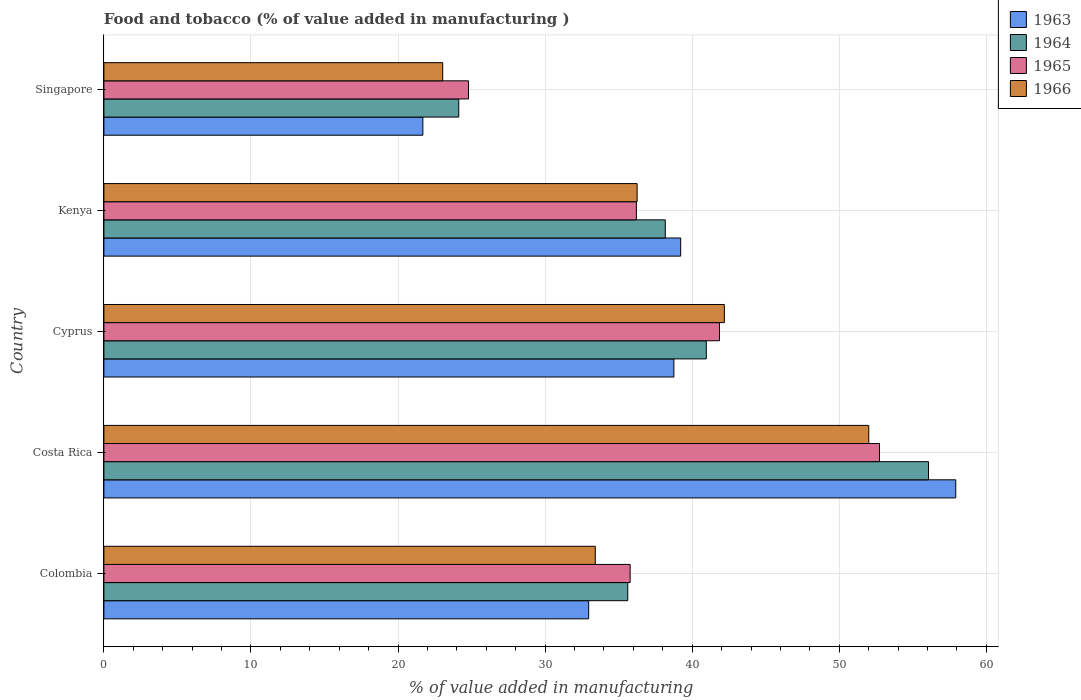How many different coloured bars are there?
Keep it short and to the point. 4. How many groups of bars are there?
Your answer should be very brief. 5. Are the number of bars on each tick of the Y-axis equal?
Make the answer very short. Yes. What is the label of the 2nd group of bars from the top?
Provide a short and direct response. Kenya. What is the value added in manufacturing food and tobacco in 1963 in Kenya?
Make the answer very short. 39.22. Across all countries, what is the maximum value added in manufacturing food and tobacco in 1965?
Ensure brevity in your answer.  52.73. Across all countries, what is the minimum value added in manufacturing food and tobacco in 1963?
Offer a terse response. 21.69. In which country was the value added in manufacturing food and tobacco in 1964 maximum?
Offer a terse response. Costa Rica. In which country was the value added in manufacturing food and tobacco in 1965 minimum?
Offer a very short reply. Singapore. What is the total value added in manufacturing food and tobacco in 1963 in the graph?
Provide a succinct answer. 190.54. What is the difference between the value added in manufacturing food and tobacco in 1964 in Colombia and that in Kenya?
Provide a succinct answer. -2.55. What is the difference between the value added in manufacturing food and tobacco in 1963 in Kenya and the value added in manufacturing food and tobacco in 1965 in Cyprus?
Your answer should be very brief. -2.64. What is the average value added in manufacturing food and tobacco in 1963 per country?
Make the answer very short. 38.11. What is the difference between the value added in manufacturing food and tobacco in 1965 and value added in manufacturing food and tobacco in 1963 in Costa Rica?
Your answer should be compact. -5.19. What is the ratio of the value added in manufacturing food and tobacco in 1966 in Colombia to that in Singapore?
Give a very brief answer. 1.45. Is the difference between the value added in manufacturing food and tobacco in 1965 in Cyprus and Singapore greater than the difference between the value added in manufacturing food and tobacco in 1963 in Cyprus and Singapore?
Provide a succinct answer. No. What is the difference between the highest and the second highest value added in manufacturing food and tobacco in 1966?
Your answer should be very brief. 9.82. What is the difference between the highest and the lowest value added in manufacturing food and tobacco in 1966?
Your answer should be compact. 28.97. What does the 3rd bar from the top in Colombia represents?
Provide a succinct answer. 1964. What does the 3rd bar from the bottom in Colombia represents?
Keep it short and to the point. 1965. Are the values on the major ticks of X-axis written in scientific E-notation?
Give a very brief answer. No. How many legend labels are there?
Provide a short and direct response. 4. What is the title of the graph?
Your response must be concise. Food and tobacco (% of value added in manufacturing ). Does "1974" appear as one of the legend labels in the graph?
Ensure brevity in your answer.  No. What is the label or title of the X-axis?
Offer a terse response. % of value added in manufacturing. What is the label or title of the Y-axis?
Provide a short and direct response. Country. What is the % of value added in manufacturing of 1963 in Colombia?
Your response must be concise. 32.96. What is the % of value added in manufacturing of 1964 in Colombia?
Keep it short and to the point. 35.62. What is the % of value added in manufacturing of 1965 in Colombia?
Make the answer very short. 35.78. What is the % of value added in manufacturing in 1966 in Colombia?
Your response must be concise. 33.41. What is the % of value added in manufacturing of 1963 in Costa Rica?
Offer a very short reply. 57.92. What is the % of value added in manufacturing of 1964 in Costa Rica?
Make the answer very short. 56.07. What is the % of value added in manufacturing of 1965 in Costa Rica?
Ensure brevity in your answer.  52.73. What is the % of value added in manufacturing of 1966 in Costa Rica?
Keep it short and to the point. 52. What is the % of value added in manufacturing of 1963 in Cyprus?
Provide a short and direct response. 38.75. What is the % of value added in manufacturing of 1964 in Cyprus?
Your answer should be compact. 40.96. What is the % of value added in manufacturing of 1965 in Cyprus?
Provide a short and direct response. 41.85. What is the % of value added in manufacturing of 1966 in Cyprus?
Provide a short and direct response. 42.19. What is the % of value added in manufacturing in 1963 in Kenya?
Offer a terse response. 39.22. What is the % of value added in manufacturing of 1964 in Kenya?
Ensure brevity in your answer.  38.17. What is the % of value added in manufacturing in 1965 in Kenya?
Give a very brief answer. 36.2. What is the % of value added in manufacturing of 1966 in Kenya?
Offer a very short reply. 36.25. What is the % of value added in manufacturing of 1963 in Singapore?
Ensure brevity in your answer.  21.69. What is the % of value added in manufacturing of 1964 in Singapore?
Keep it short and to the point. 24.13. What is the % of value added in manufacturing in 1965 in Singapore?
Your answer should be very brief. 24.79. What is the % of value added in manufacturing of 1966 in Singapore?
Your answer should be very brief. 23.04. Across all countries, what is the maximum % of value added in manufacturing in 1963?
Keep it short and to the point. 57.92. Across all countries, what is the maximum % of value added in manufacturing of 1964?
Make the answer very short. 56.07. Across all countries, what is the maximum % of value added in manufacturing in 1965?
Your response must be concise. 52.73. Across all countries, what is the maximum % of value added in manufacturing of 1966?
Your answer should be very brief. 52. Across all countries, what is the minimum % of value added in manufacturing in 1963?
Your response must be concise. 21.69. Across all countries, what is the minimum % of value added in manufacturing in 1964?
Offer a terse response. 24.13. Across all countries, what is the minimum % of value added in manufacturing of 1965?
Offer a terse response. 24.79. Across all countries, what is the minimum % of value added in manufacturing in 1966?
Your response must be concise. 23.04. What is the total % of value added in manufacturing in 1963 in the graph?
Ensure brevity in your answer.  190.54. What is the total % of value added in manufacturing in 1964 in the graph?
Offer a very short reply. 194.94. What is the total % of value added in manufacturing of 1965 in the graph?
Give a very brief answer. 191.36. What is the total % of value added in manufacturing of 1966 in the graph?
Offer a very short reply. 186.89. What is the difference between the % of value added in manufacturing of 1963 in Colombia and that in Costa Rica?
Provide a succinct answer. -24.96. What is the difference between the % of value added in manufacturing in 1964 in Colombia and that in Costa Rica?
Your answer should be very brief. -20.45. What is the difference between the % of value added in manufacturing of 1965 in Colombia and that in Costa Rica?
Provide a short and direct response. -16.95. What is the difference between the % of value added in manufacturing in 1966 in Colombia and that in Costa Rica?
Give a very brief answer. -18.59. What is the difference between the % of value added in manufacturing of 1963 in Colombia and that in Cyprus?
Make the answer very short. -5.79. What is the difference between the % of value added in manufacturing of 1964 in Colombia and that in Cyprus?
Ensure brevity in your answer.  -5.34. What is the difference between the % of value added in manufacturing in 1965 in Colombia and that in Cyprus?
Offer a terse response. -6.07. What is the difference between the % of value added in manufacturing in 1966 in Colombia and that in Cyprus?
Offer a very short reply. -8.78. What is the difference between the % of value added in manufacturing in 1963 in Colombia and that in Kenya?
Your answer should be compact. -6.26. What is the difference between the % of value added in manufacturing of 1964 in Colombia and that in Kenya?
Provide a succinct answer. -2.55. What is the difference between the % of value added in manufacturing in 1965 in Colombia and that in Kenya?
Make the answer very short. -0.42. What is the difference between the % of value added in manufacturing in 1966 in Colombia and that in Kenya?
Your response must be concise. -2.84. What is the difference between the % of value added in manufacturing in 1963 in Colombia and that in Singapore?
Your response must be concise. 11.27. What is the difference between the % of value added in manufacturing of 1964 in Colombia and that in Singapore?
Provide a short and direct response. 11.49. What is the difference between the % of value added in manufacturing of 1965 in Colombia and that in Singapore?
Your answer should be very brief. 10.99. What is the difference between the % of value added in manufacturing in 1966 in Colombia and that in Singapore?
Provide a short and direct response. 10.37. What is the difference between the % of value added in manufacturing in 1963 in Costa Rica and that in Cyprus?
Offer a very short reply. 19.17. What is the difference between the % of value added in manufacturing of 1964 in Costa Rica and that in Cyprus?
Provide a succinct answer. 15.11. What is the difference between the % of value added in manufacturing in 1965 in Costa Rica and that in Cyprus?
Your response must be concise. 10.88. What is the difference between the % of value added in manufacturing in 1966 in Costa Rica and that in Cyprus?
Make the answer very short. 9.82. What is the difference between the % of value added in manufacturing of 1963 in Costa Rica and that in Kenya?
Offer a very short reply. 18.7. What is the difference between the % of value added in manufacturing of 1964 in Costa Rica and that in Kenya?
Give a very brief answer. 17.9. What is the difference between the % of value added in manufacturing in 1965 in Costa Rica and that in Kenya?
Your answer should be compact. 16.53. What is the difference between the % of value added in manufacturing of 1966 in Costa Rica and that in Kenya?
Give a very brief answer. 15.75. What is the difference between the % of value added in manufacturing in 1963 in Costa Rica and that in Singapore?
Give a very brief answer. 36.23. What is the difference between the % of value added in manufacturing of 1964 in Costa Rica and that in Singapore?
Offer a very short reply. 31.94. What is the difference between the % of value added in manufacturing in 1965 in Costa Rica and that in Singapore?
Make the answer very short. 27.94. What is the difference between the % of value added in manufacturing in 1966 in Costa Rica and that in Singapore?
Offer a terse response. 28.97. What is the difference between the % of value added in manufacturing in 1963 in Cyprus and that in Kenya?
Ensure brevity in your answer.  -0.46. What is the difference between the % of value added in manufacturing in 1964 in Cyprus and that in Kenya?
Ensure brevity in your answer.  2.79. What is the difference between the % of value added in manufacturing in 1965 in Cyprus and that in Kenya?
Your response must be concise. 5.65. What is the difference between the % of value added in manufacturing in 1966 in Cyprus and that in Kenya?
Offer a terse response. 5.93. What is the difference between the % of value added in manufacturing in 1963 in Cyprus and that in Singapore?
Your response must be concise. 17.07. What is the difference between the % of value added in manufacturing in 1964 in Cyprus and that in Singapore?
Offer a very short reply. 16.83. What is the difference between the % of value added in manufacturing in 1965 in Cyprus and that in Singapore?
Offer a terse response. 17.06. What is the difference between the % of value added in manufacturing of 1966 in Cyprus and that in Singapore?
Keep it short and to the point. 19.15. What is the difference between the % of value added in manufacturing of 1963 in Kenya and that in Singapore?
Your response must be concise. 17.53. What is the difference between the % of value added in manufacturing in 1964 in Kenya and that in Singapore?
Make the answer very short. 14.04. What is the difference between the % of value added in manufacturing of 1965 in Kenya and that in Singapore?
Offer a terse response. 11.41. What is the difference between the % of value added in manufacturing in 1966 in Kenya and that in Singapore?
Provide a succinct answer. 13.22. What is the difference between the % of value added in manufacturing in 1963 in Colombia and the % of value added in manufacturing in 1964 in Costa Rica?
Your answer should be compact. -23.11. What is the difference between the % of value added in manufacturing of 1963 in Colombia and the % of value added in manufacturing of 1965 in Costa Rica?
Your answer should be compact. -19.77. What is the difference between the % of value added in manufacturing in 1963 in Colombia and the % of value added in manufacturing in 1966 in Costa Rica?
Your answer should be very brief. -19.04. What is the difference between the % of value added in manufacturing in 1964 in Colombia and the % of value added in manufacturing in 1965 in Costa Rica?
Your answer should be compact. -17.11. What is the difference between the % of value added in manufacturing in 1964 in Colombia and the % of value added in manufacturing in 1966 in Costa Rica?
Your response must be concise. -16.38. What is the difference between the % of value added in manufacturing of 1965 in Colombia and the % of value added in manufacturing of 1966 in Costa Rica?
Provide a short and direct response. -16.22. What is the difference between the % of value added in manufacturing in 1963 in Colombia and the % of value added in manufacturing in 1964 in Cyprus?
Your answer should be compact. -8. What is the difference between the % of value added in manufacturing of 1963 in Colombia and the % of value added in manufacturing of 1965 in Cyprus?
Keep it short and to the point. -8.89. What is the difference between the % of value added in manufacturing in 1963 in Colombia and the % of value added in manufacturing in 1966 in Cyprus?
Provide a succinct answer. -9.23. What is the difference between the % of value added in manufacturing in 1964 in Colombia and the % of value added in manufacturing in 1965 in Cyprus?
Provide a short and direct response. -6.23. What is the difference between the % of value added in manufacturing of 1964 in Colombia and the % of value added in manufacturing of 1966 in Cyprus?
Provide a short and direct response. -6.57. What is the difference between the % of value added in manufacturing in 1965 in Colombia and the % of value added in manufacturing in 1966 in Cyprus?
Offer a very short reply. -6.41. What is the difference between the % of value added in manufacturing in 1963 in Colombia and the % of value added in manufacturing in 1964 in Kenya?
Your response must be concise. -5.21. What is the difference between the % of value added in manufacturing of 1963 in Colombia and the % of value added in manufacturing of 1965 in Kenya?
Your response must be concise. -3.24. What is the difference between the % of value added in manufacturing of 1963 in Colombia and the % of value added in manufacturing of 1966 in Kenya?
Give a very brief answer. -3.29. What is the difference between the % of value added in manufacturing of 1964 in Colombia and the % of value added in manufacturing of 1965 in Kenya?
Give a very brief answer. -0.58. What is the difference between the % of value added in manufacturing of 1964 in Colombia and the % of value added in manufacturing of 1966 in Kenya?
Your answer should be very brief. -0.63. What is the difference between the % of value added in manufacturing of 1965 in Colombia and the % of value added in manufacturing of 1966 in Kenya?
Give a very brief answer. -0.47. What is the difference between the % of value added in manufacturing of 1963 in Colombia and the % of value added in manufacturing of 1964 in Singapore?
Provide a succinct answer. 8.83. What is the difference between the % of value added in manufacturing in 1963 in Colombia and the % of value added in manufacturing in 1965 in Singapore?
Make the answer very short. 8.17. What is the difference between the % of value added in manufacturing of 1963 in Colombia and the % of value added in manufacturing of 1966 in Singapore?
Provide a short and direct response. 9.92. What is the difference between the % of value added in manufacturing in 1964 in Colombia and the % of value added in manufacturing in 1965 in Singapore?
Give a very brief answer. 10.83. What is the difference between the % of value added in manufacturing in 1964 in Colombia and the % of value added in manufacturing in 1966 in Singapore?
Ensure brevity in your answer.  12.58. What is the difference between the % of value added in manufacturing in 1965 in Colombia and the % of value added in manufacturing in 1966 in Singapore?
Give a very brief answer. 12.74. What is the difference between the % of value added in manufacturing in 1963 in Costa Rica and the % of value added in manufacturing in 1964 in Cyprus?
Give a very brief answer. 16.96. What is the difference between the % of value added in manufacturing of 1963 in Costa Rica and the % of value added in manufacturing of 1965 in Cyprus?
Ensure brevity in your answer.  16.07. What is the difference between the % of value added in manufacturing in 1963 in Costa Rica and the % of value added in manufacturing in 1966 in Cyprus?
Provide a short and direct response. 15.73. What is the difference between the % of value added in manufacturing in 1964 in Costa Rica and the % of value added in manufacturing in 1965 in Cyprus?
Provide a short and direct response. 14.21. What is the difference between the % of value added in manufacturing in 1964 in Costa Rica and the % of value added in manufacturing in 1966 in Cyprus?
Provide a succinct answer. 13.88. What is the difference between the % of value added in manufacturing of 1965 in Costa Rica and the % of value added in manufacturing of 1966 in Cyprus?
Make the answer very short. 10.55. What is the difference between the % of value added in manufacturing in 1963 in Costa Rica and the % of value added in manufacturing in 1964 in Kenya?
Provide a short and direct response. 19.75. What is the difference between the % of value added in manufacturing of 1963 in Costa Rica and the % of value added in manufacturing of 1965 in Kenya?
Provide a succinct answer. 21.72. What is the difference between the % of value added in manufacturing of 1963 in Costa Rica and the % of value added in manufacturing of 1966 in Kenya?
Your response must be concise. 21.67. What is the difference between the % of value added in manufacturing of 1964 in Costa Rica and the % of value added in manufacturing of 1965 in Kenya?
Provide a succinct answer. 19.86. What is the difference between the % of value added in manufacturing in 1964 in Costa Rica and the % of value added in manufacturing in 1966 in Kenya?
Your answer should be very brief. 19.81. What is the difference between the % of value added in manufacturing in 1965 in Costa Rica and the % of value added in manufacturing in 1966 in Kenya?
Ensure brevity in your answer.  16.48. What is the difference between the % of value added in manufacturing in 1963 in Costa Rica and the % of value added in manufacturing in 1964 in Singapore?
Provide a succinct answer. 33.79. What is the difference between the % of value added in manufacturing of 1963 in Costa Rica and the % of value added in manufacturing of 1965 in Singapore?
Your answer should be very brief. 33.13. What is the difference between the % of value added in manufacturing in 1963 in Costa Rica and the % of value added in manufacturing in 1966 in Singapore?
Make the answer very short. 34.88. What is the difference between the % of value added in manufacturing in 1964 in Costa Rica and the % of value added in manufacturing in 1965 in Singapore?
Offer a very short reply. 31.28. What is the difference between the % of value added in manufacturing in 1964 in Costa Rica and the % of value added in manufacturing in 1966 in Singapore?
Keep it short and to the point. 33.03. What is the difference between the % of value added in manufacturing of 1965 in Costa Rica and the % of value added in manufacturing of 1966 in Singapore?
Your answer should be compact. 29.7. What is the difference between the % of value added in manufacturing of 1963 in Cyprus and the % of value added in manufacturing of 1964 in Kenya?
Your answer should be compact. 0.59. What is the difference between the % of value added in manufacturing in 1963 in Cyprus and the % of value added in manufacturing in 1965 in Kenya?
Provide a short and direct response. 2.55. What is the difference between the % of value added in manufacturing of 1963 in Cyprus and the % of value added in manufacturing of 1966 in Kenya?
Your answer should be compact. 2.5. What is the difference between the % of value added in manufacturing in 1964 in Cyprus and the % of value added in manufacturing in 1965 in Kenya?
Offer a very short reply. 4.75. What is the difference between the % of value added in manufacturing in 1964 in Cyprus and the % of value added in manufacturing in 1966 in Kenya?
Offer a terse response. 4.7. What is the difference between the % of value added in manufacturing of 1965 in Cyprus and the % of value added in manufacturing of 1966 in Kenya?
Offer a terse response. 5.6. What is the difference between the % of value added in manufacturing in 1963 in Cyprus and the % of value added in manufacturing in 1964 in Singapore?
Offer a terse response. 14.63. What is the difference between the % of value added in manufacturing of 1963 in Cyprus and the % of value added in manufacturing of 1965 in Singapore?
Keep it short and to the point. 13.96. What is the difference between the % of value added in manufacturing in 1963 in Cyprus and the % of value added in manufacturing in 1966 in Singapore?
Give a very brief answer. 15.72. What is the difference between the % of value added in manufacturing in 1964 in Cyprus and the % of value added in manufacturing in 1965 in Singapore?
Ensure brevity in your answer.  16.17. What is the difference between the % of value added in manufacturing in 1964 in Cyprus and the % of value added in manufacturing in 1966 in Singapore?
Your response must be concise. 17.92. What is the difference between the % of value added in manufacturing in 1965 in Cyprus and the % of value added in manufacturing in 1966 in Singapore?
Provide a short and direct response. 18.82. What is the difference between the % of value added in manufacturing in 1963 in Kenya and the % of value added in manufacturing in 1964 in Singapore?
Make the answer very short. 15.09. What is the difference between the % of value added in manufacturing of 1963 in Kenya and the % of value added in manufacturing of 1965 in Singapore?
Your answer should be compact. 14.43. What is the difference between the % of value added in manufacturing in 1963 in Kenya and the % of value added in manufacturing in 1966 in Singapore?
Give a very brief answer. 16.18. What is the difference between the % of value added in manufacturing in 1964 in Kenya and the % of value added in manufacturing in 1965 in Singapore?
Your answer should be compact. 13.38. What is the difference between the % of value added in manufacturing of 1964 in Kenya and the % of value added in manufacturing of 1966 in Singapore?
Offer a terse response. 15.13. What is the difference between the % of value added in manufacturing in 1965 in Kenya and the % of value added in manufacturing in 1966 in Singapore?
Your answer should be compact. 13.17. What is the average % of value added in manufacturing in 1963 per country?
Offer a very short reply. 38.11. What is the average % of value added in manufacturing of 1964 per country?
Keep it short and to the point. 38.99. What is the average % of value added in manufacturing in 1965 per country?
Your answer should be compact. 38.27. What is the average % of value added in manufacturing of 1966 per country?
Ensure brevity in your answer.  37.38. What is the difference between the % of value added in manufacturing in 1963 and % of value added in manufacturing in 1964 in Colombia?
Your response must be concise. -2.66. What is the difference between the % of value added in manufacturing in 1963 and % of value added in manufacturing in 1965 in Colombia?
Offer a very short reply. -2.82. What is the difference between the % of value added in manufacturing in 1963 and % of value added in manufacturing in 1966 in Colombia?
Offer a terse response. -0.45. What is the difference between the % of value added in manufacturing in 1964 and % of value added in manufacturing in 1965 in Colombia?
Provide a succinct answer. -0.16. What is the difference between the % of value added in manufacturing of 1964 and % of value added in manufacturing of 1966 in Colombia?
Your answer should be compact. 2.21. What is the difference between the % of value added in manufacturing in 1965 and % of value added in manufacturing in 1966 in Colombia?
Your answer should be compact. 2.37. What is the difference between the % of value added in manufacturing in 1963 and % of value added in manufacturing in 1964 in Costa Rica?
Provide a short and direct response. 1.85. What is the difference between the % of value added in manufacturing in 1963 and % of value added in manufacturing in 1965 in Costa Rica?
Provide a succinct answer. 5.19. What is the difference between the % of value added in manufacturing in 1963 and % of value added in manufacturing in 1966 in Costa Rica?
Your answer should be very brief. 5.92. What is the difference between the % of value added in manufacturing in 1964 and % of value added in manufacturing in 1965 in Costa Rica?
Provide a succinct answer. 3.33. What is the difference between the % of value added in manufacturing of 1964 and % of value added in manufacturing of 1966 in Costa Rica?
Your answer should be compact. 4.06. What is the difference between the % of value added in manufacturing of 1965 and % of value added in manufacturing of 1966 in Costa Rica?
Provide a succinct answer. 0.73. What is the difference between the % of value added in manufacturing in 1963 and % of value added in manufacturing in 1964 in Cyprus?
Provide a short and direct response. -2.2. What is the difference between the % of value added in manufacturing in 1963 and % of value added in manufacturing in 1965 in Cyprus?
Provide a short and direct response. -3.1. What is the difference between the % of value added in manufacturing of 1963 and % of value added in manufacturing of 1966 in Cyprus?
Provide a short and direct response. -3.43. What is the difference between the % of value added in manufacturing in 1964 and % of value added in manufacturing in 1965 in Cyprus?
Make the answer very short. -0.9. What is the difference between the % of value added in manufacturing of 1964 and % of value added in manufacturing of 1966 in Cyprus?
Your answer should be compact. -1.23. What is the difference between the % of value added in manufacturing of 1963 and % of value added in manufacturing of 1964 in Kenya?
Offer a very short reply. 1.05. What is the difference between the % of value added in manufacturing of 1963 and % of value added in manufacturing of 1965 in Kenya?
Give a very brief answer. 3.01. What is the difference between the % of value added in manufacturing in 1963 and % of value added in manufacturing in 1966 in Kenya?
Make the answer very short. 2.96. What is the difference between the % of value added in manufacturing in 1964 and % of value added in manufacturing in 1965 in Kenya?
Your answer should be compact. 1.96. What is the difference between the % of value added in manufacturing of 1964 and % of value added in manufacturing of 1966 in Kenya?
Your answer should be compact. 1.91. What is the difference between the % of value added in manufacturing of 1963 and % of value added in manufacturing of 1964 in Singapore?
Provide a succinct answer. -2.44. What is the difference between the % of value added in manufacturing in 1963 and % of value added in manufacturing in 1965 in Singapore?
Provide a succinct answer. -3.1. What is the difference between the % of value added in manufacturing of 1963 and % of value added in manufacturing of 1966 in Singapore?
Make the answer very short. -1.35. What is the difference between the % of value added in manufacturing in 1964 and % of value added in manufacturing in 1965 in Singapore?
Provide a succinct answer. -0.66. What is the difference between the % of value added in manufacturing in 1964 and % of value added in manufacturing in 1966 in Singapore?
Provide a short and direct response. 1.09. What is the difference between the % of value added in manufacturing in 1965 and % of value added in manufacturing in 1966 in Singapore?
Offer a terse response. 1.75. What is the ratio of the % of value added in manufacturing in 1963 in Colombia to that in Costa Rica?
Your answer should be very brief. 0.57. What is the ratio of the % of value added in manufacturing in 1964 in Colombia to that in Costa Rica?
Make the answer very short. 0.64. What is the ratio of the % of value added in manufacturing in 1965 in Colombia to that in Costa Rica?
Offer a very short reply. 0.68. What is the ratio of the % of value added in manufacturing in 1966 in Colombia to that in Costa Rica?
Offer a very short reply. 0.64. What is the ratio of the % of value added in manufacturing of 1963 in Colombia to that in Cyprus?
Keep it short and to the point. 0.85. What is the ratio of the % of value added in manufacturing of 1964 in Colombia to that in Cyprus?
Your answer should be compact. 0.87. What is the ratio of the % of value added in manufacturing in 1965 in Colombia to that in Cyprus?
Provide a short and direct response. 0.85. What is the ratio of the % of value added in manufacturing in 1966 in Colombia to that in Cyprus?
Keep it short and to the point. 0.79. What is the ratio of the % of value added in manufacturing of 1963 in Colombia to that in Kenya?
Keep it short and to the point. 0.84. What is the ratio of the % of value added in manufacturing in 1964 in Colombia to that in Kenya?
Keep it short and to the point. 0.93. What is the ratio of the % of value added in manufacturing in 1965 in Colombia to that in Kenya?
Provide a succinct answer. 0.99. What is the ratio of the % of value added in manufacturing of 1966 in Colombia to that in Kenya?
Your response must be concise. 0.92. What is the ratio of the % of value added in manufacturing of 1963 in Colombia to that in Singapore?
Provide a short and direct response. 1.52. What is the ratio of the % of value added in manufacturing in 1964 in Colombia to that in Singapore?
Your answer should be very brief. 1.48. What is the ratio of the % of value added in manufacturing of 1965 in Colombia to that in Singapore?
Your answer should be very brief. 1.44. What is the ratio of the % of value added in manufacturing of 1966 in Colombia to that in Singapore?
Your response must be concise. 1.45. What is the ratio of the % of value added in manufacturing in 1963 in Costa Rica to that in Cyprus?
Keep it short and to the point. 1.49. What is the ratio of the % of value added in manufacturing in 1964 in Costa Rica to that in Cyprus?
Your response must be concise. 1.37. What is the ratio of the % of value added in manufacturing of 1965 in Costa Rica to that in Cyprus?
Your answer should be very brief. 1.26. What is the ratio of the % of value added in manufacturing of 1966 in Costa Rica to that in Cyprus?
Keep it short and to the point. 1.23. What is the ratio of the % of value added in manufacturing of 1963 in Costa Rica to that in Kenya?
Make the answer very short. 1.48. What is the ratio of the % of value added in manufacturing of 1964 in Costa Rica to that in Kenya?
Give a very brief answer. 1.47. What is the ratio of the % of value added in manufacturing of 1965 in Costa Rica to that in Kenya?
Give a very brief answer. 1.46. What is the ratio of the % of value added in manufacturing in 1966 in Costa Rica to that in Kenya?
Make the answer very short. 1.43. What is the ratio of the % of value added in manufacturing in 1963 in Costa Rica to that in Singapore?
Your answer should be very brief. 2.67. What is the ratio of the % of value added in manufacturing of 1964 in Costa Rica to that in Singapore?
Your answer should be compact. 2.32. What is the ratio of the % of value added in manufacturing of 1965 in Costa Rica to that in Singapore?
Give a very brief answer. 2.13. What is the ratio of the % of value added in manufacturing in 1966 in Costa Rica to that in Singapore?
Your response must be concise. 2.26. What is the ratio of the % of value added in manufacturing in 1964 in Cyprus to that in Kenya?
Provide a short and direct response. 1.07. What is the ratio of the % of value added in manufacturing of 1965 in Cyprus to that in Kenya?
Your response must be concise. 1.16. What is the ratio of the % of value added in manufacturing of 1966 in Cyprus to that in Kenya?
Ensure brevity in your answer.  1.16. What is the ratio of the % of value added in manufacturing in 1963 in Cyprus to that in Singapore?
Provide a succinct answer. 1.79. What is the ratio of the % of value added in manufacturing in 1964 in Cyprus to that in Singapore?
Make the answer very short. 1.7. What is the ratio of the % of value added in manufacturing in 1965 in Cyprus to that in Singapore?
Make the answer very short. 1.69. What is the ratio of the % of value added in manufacturing in 1966 in Cyprus to that in Singapore?
Your response must be concise. 1.83. What is the ratio of the % of value added in manufacturing of 1963 in Kenya to that in Singapore?
Provide a short and direct response. 1.81. What is the ratio of the % of value added in manufacturing of 1964 in Kenya to that in Singapore?
Ensure brevity in your answer.  1.58. What is the ratio of the % of value added in manufacturing in 1965 in Kenya to that in Singapore?
Ensure brevity in your answer.  1.46. What is the ratio of the % of value added in manufacturing in 1966 in Kenya to that in Singapore?
Give a very brief answer. 1.57. What is the difference between the highest and the second highest % of value added in manufacturing of 1963?
Your answer should be very brief. 18.7. What is the difference between the highest and the second highest % of value added in manufacturing in 1964?
Offer a very short reply. 15.11. What is the difference between the highest and the second highest % of value added in manufacturing of 1965?
Ensure brevity in your answer.  10.88. What is the difference between the highest and the second highest % of value added in manufacturing of 1966?
Provide a short and direct response. 9.82. What is the difference between the highest and the lowest % of value added in manufacturing in 1963?
Ensure brevity in your answer.  36.23. What is the difference between the highest and the lowest % of value added in manufacturing of 1964?
Offer a terse response. 31.94. What is the difference between the highest and the lowest % of value added in manufacturing of 1965?
Make the answer very short. 27.94. What is the difference between the highest and the lowest % of value added in manufacturing of 1966?
Your response must be concise. 28.97. 